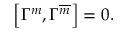Convert formula to latex. <formula><loc_0><loc_0><loc_500><loc_500>\left [ \Gamma ^ { m } , \Gamma ^ { \overline { m } } \right ] = 0 .</formula> 